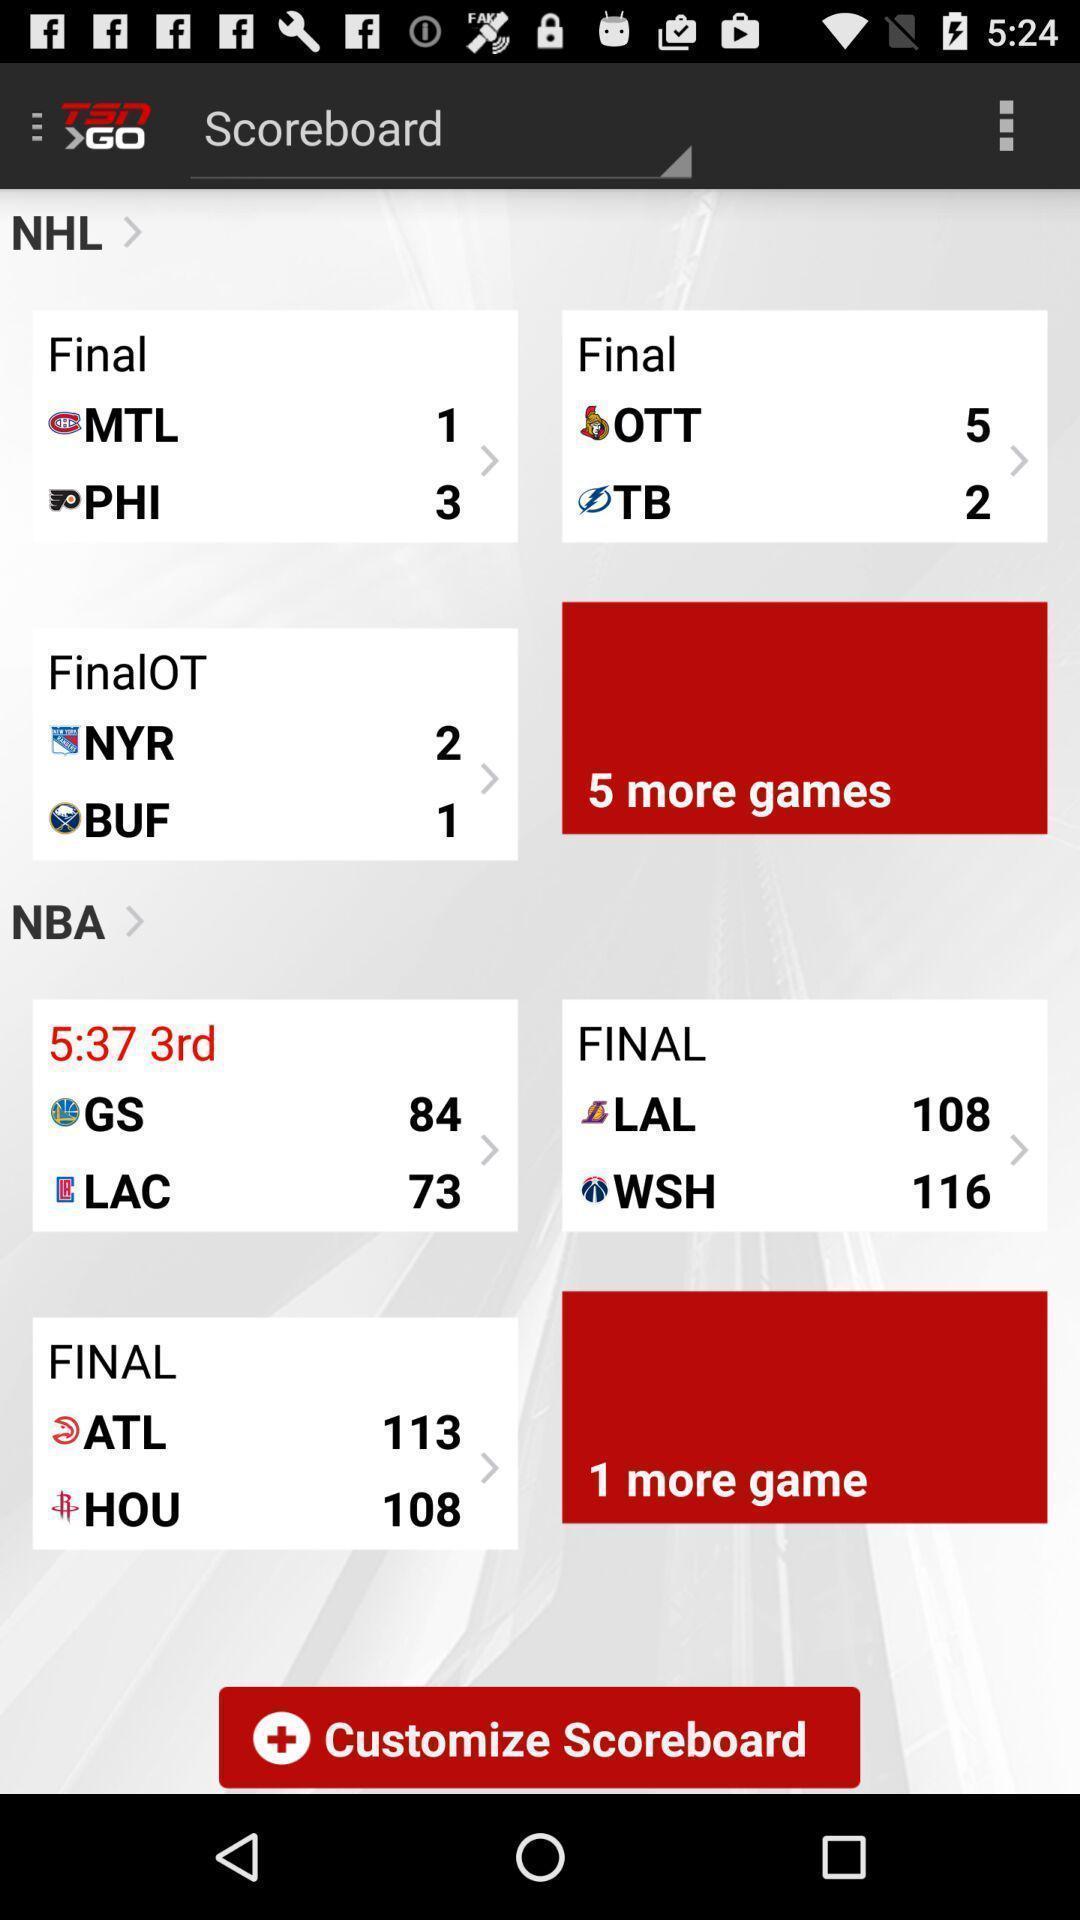Provide a textual representation of this image. Screen displaying the page of a sports app. 